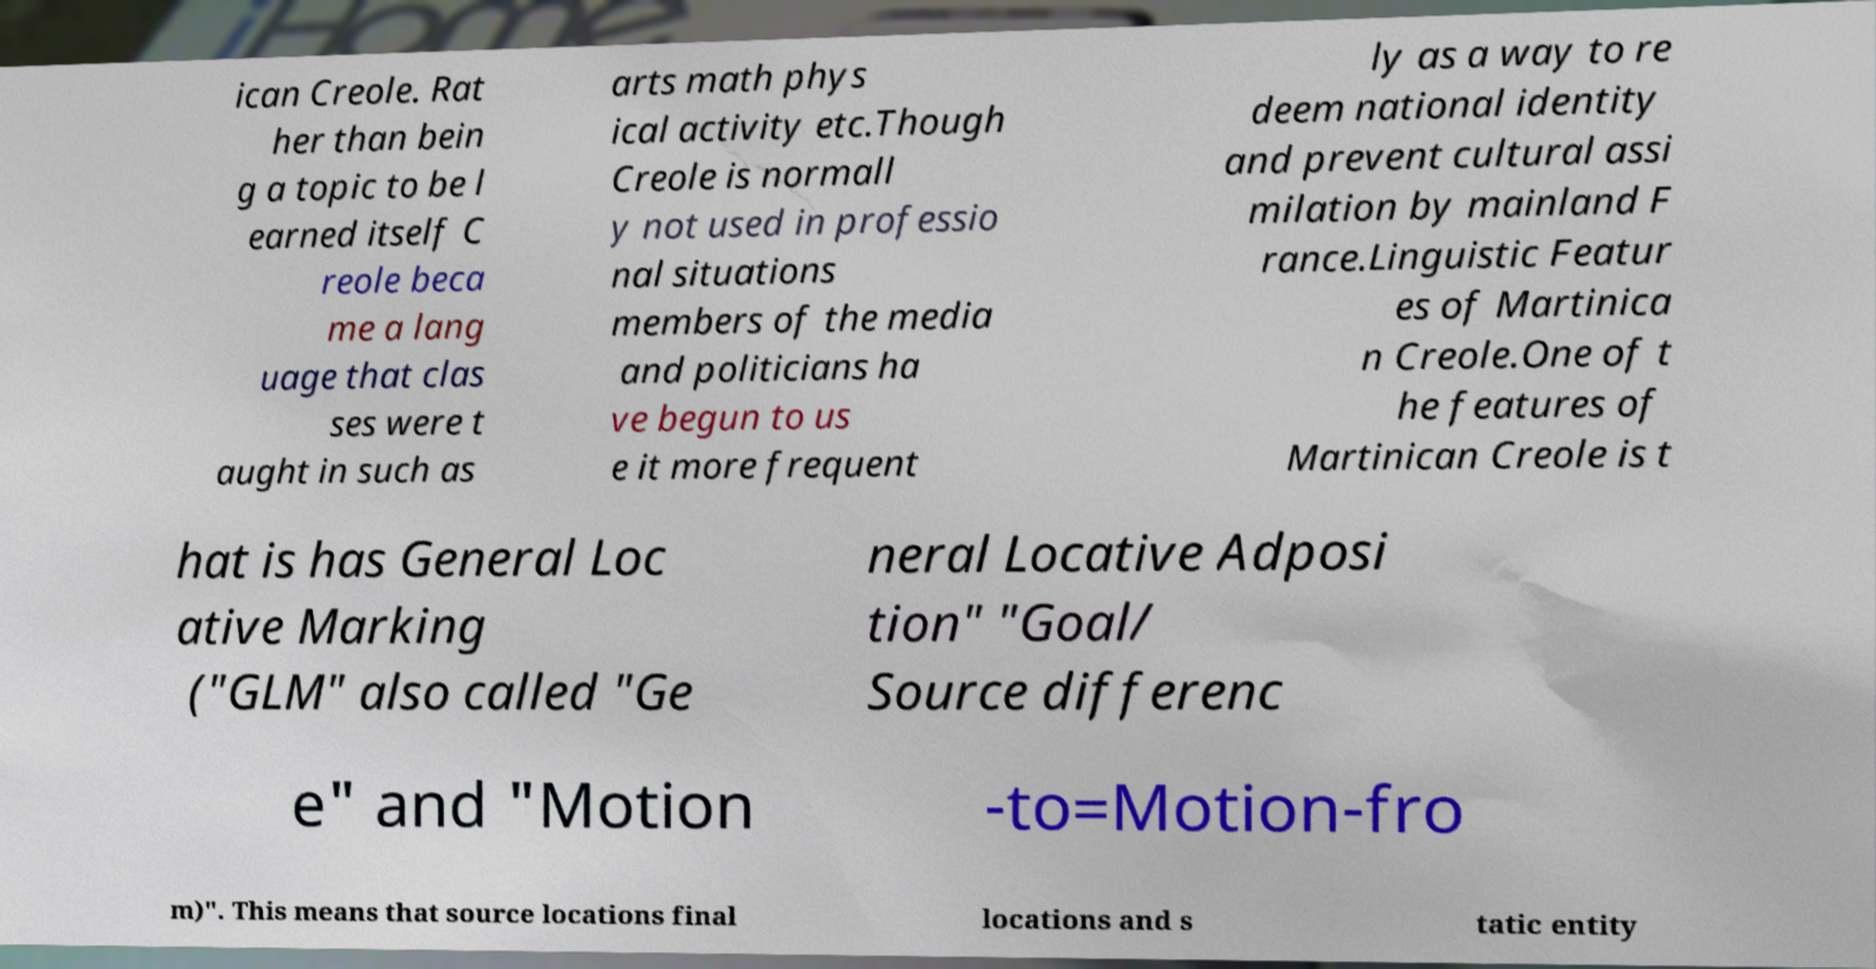There's text embedded in this image that I need extracted. Can you transcribe it verbatim? ican Creole. Rat her than bein g a topic to be l earned itself C reole beca me a lang uage that clas ses were t aught in such as arts math phys ical activity etc.Though Creole is normall y not used in professio nal situations members of the media and politicians ha ve begun to us e it more frequent ly as a way to re deem national identity and prevent cultural assi milation by mainland F rance.Linguistic Featur es of Martinica n Creole.One of t he features of Martinican Creole is t hat is has General Loc ative Marking ("GLM" also called "Ge neral Locative Adposi tion" "Goal/ Source differenc e" and "Motion -to=Motion-fro m)". This means that source locations final locations and s tatic entity 